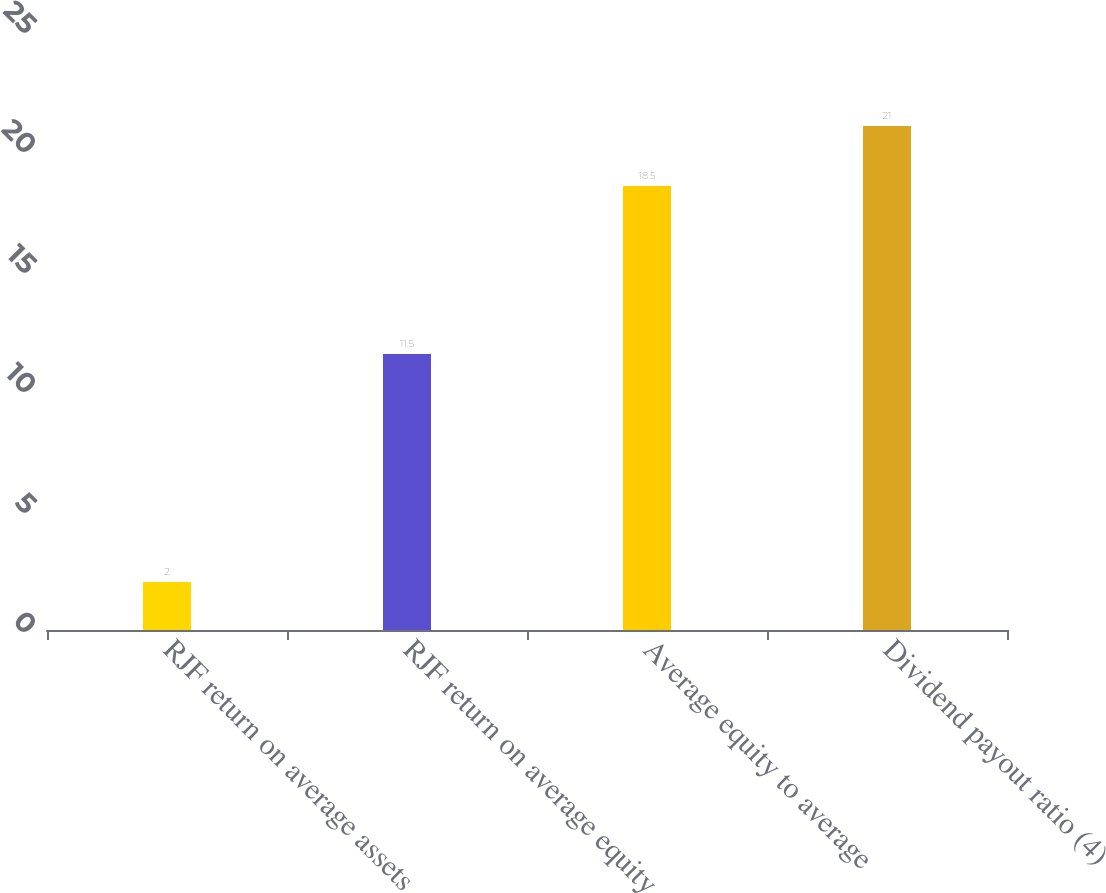Convert chart to OTSL. <chart><loc_0><loc_0><loc_500><loc_500><bar_chart><fcel>RJF return on average assets<fcel>RJF return on average equity<fcel>Average equity to average<fcel>Dividend payout ratio (4)<nl><fcel>2<fcel>11.5<fcel>18.5<fcel>21<nl></chart> 